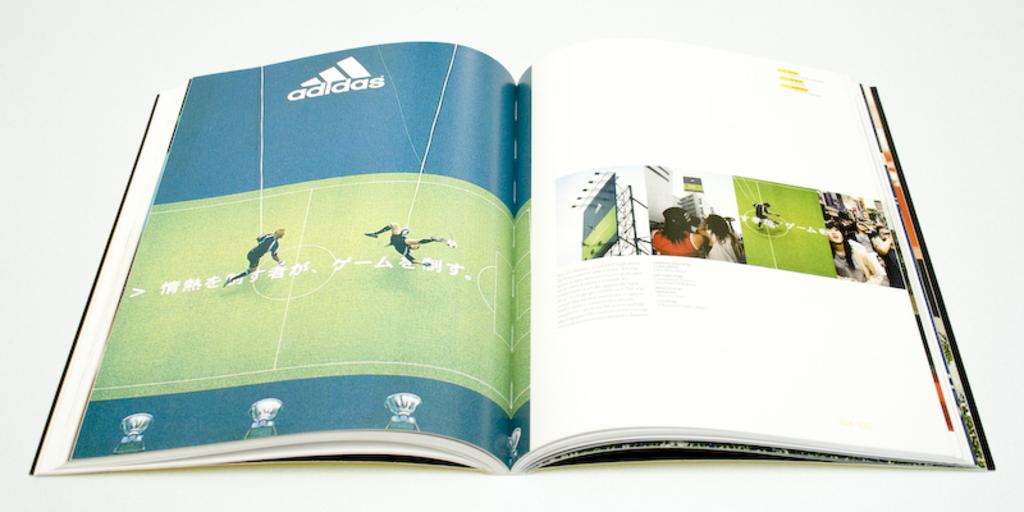Is adidas at the top of the left page?
Provide a short and direct response. Yes. 